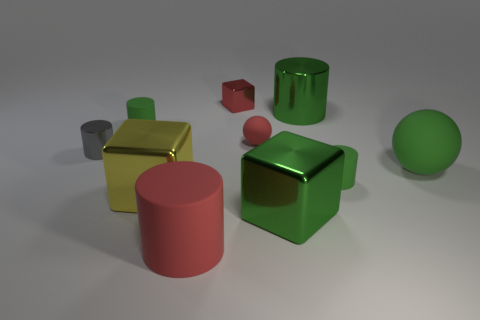Are the red block and the green ball made of the same material?
Give a very brief answer. No. There is a cylinder that is the same color as the small rubber sphere; what is its size?
Your answer should be very brief. Large. The cylinder that is to the right of the large green metal object that is behind the yellow object is made of what material?
Provide a short and direct response. Rubber. Is there a small rubber object that has the same color as the big rubber sphere?
Your response must be concise. Yes. There is a big cylinder that is behind the large green matte object; what material is it?
Keep it short and to the point. Metal. Does the big object in front of the large green cube have the same material as the small red thing that is to the left of the red ball?
Provide a succinct answer. No. Are there the same number of big green shiny blocks that are behind the gray cylinder and big matte spheres that are to the left of the big green metallic cylinder?
Ensure brevity in your answer.  Yes. How many tiny cyan cylinders have the same material as the yellow block?
Give a very brief answer. 0. What is the shape of the metallic thing that is the same color as the tiny ball?
Make the answer very short. Cube. There is a red matte thing right of the red rubber thing in front of the large green shiny cube; what size is it?
Ensure brevity in your answer.  Small. 